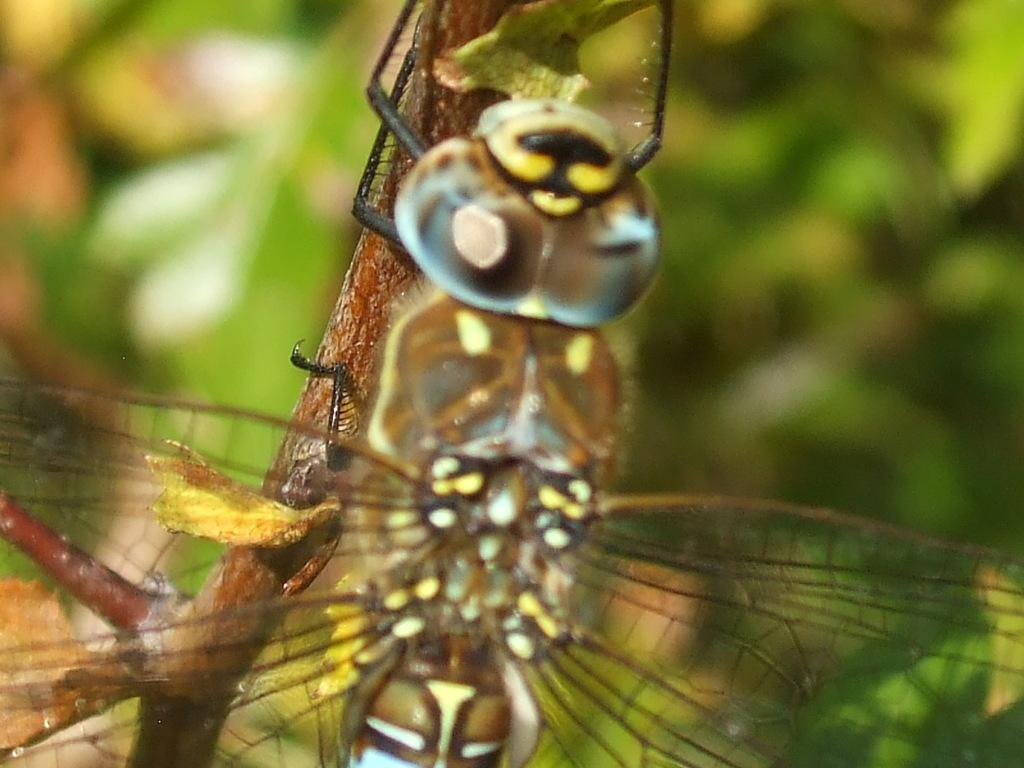What type of living organism can be seen in the image? There is an insect in the image. Can you describe the insect's location? The insect is on a brown color plant stem. What color is the background of the image? The background of the image is green. What type of growth can be seen hanging from the plant stem in the image? There is no growth hanging from the plant stem in the image; it only features an insect on the stem. Can you tell me how many toads are visible in the image? There are no toads present in the image. 